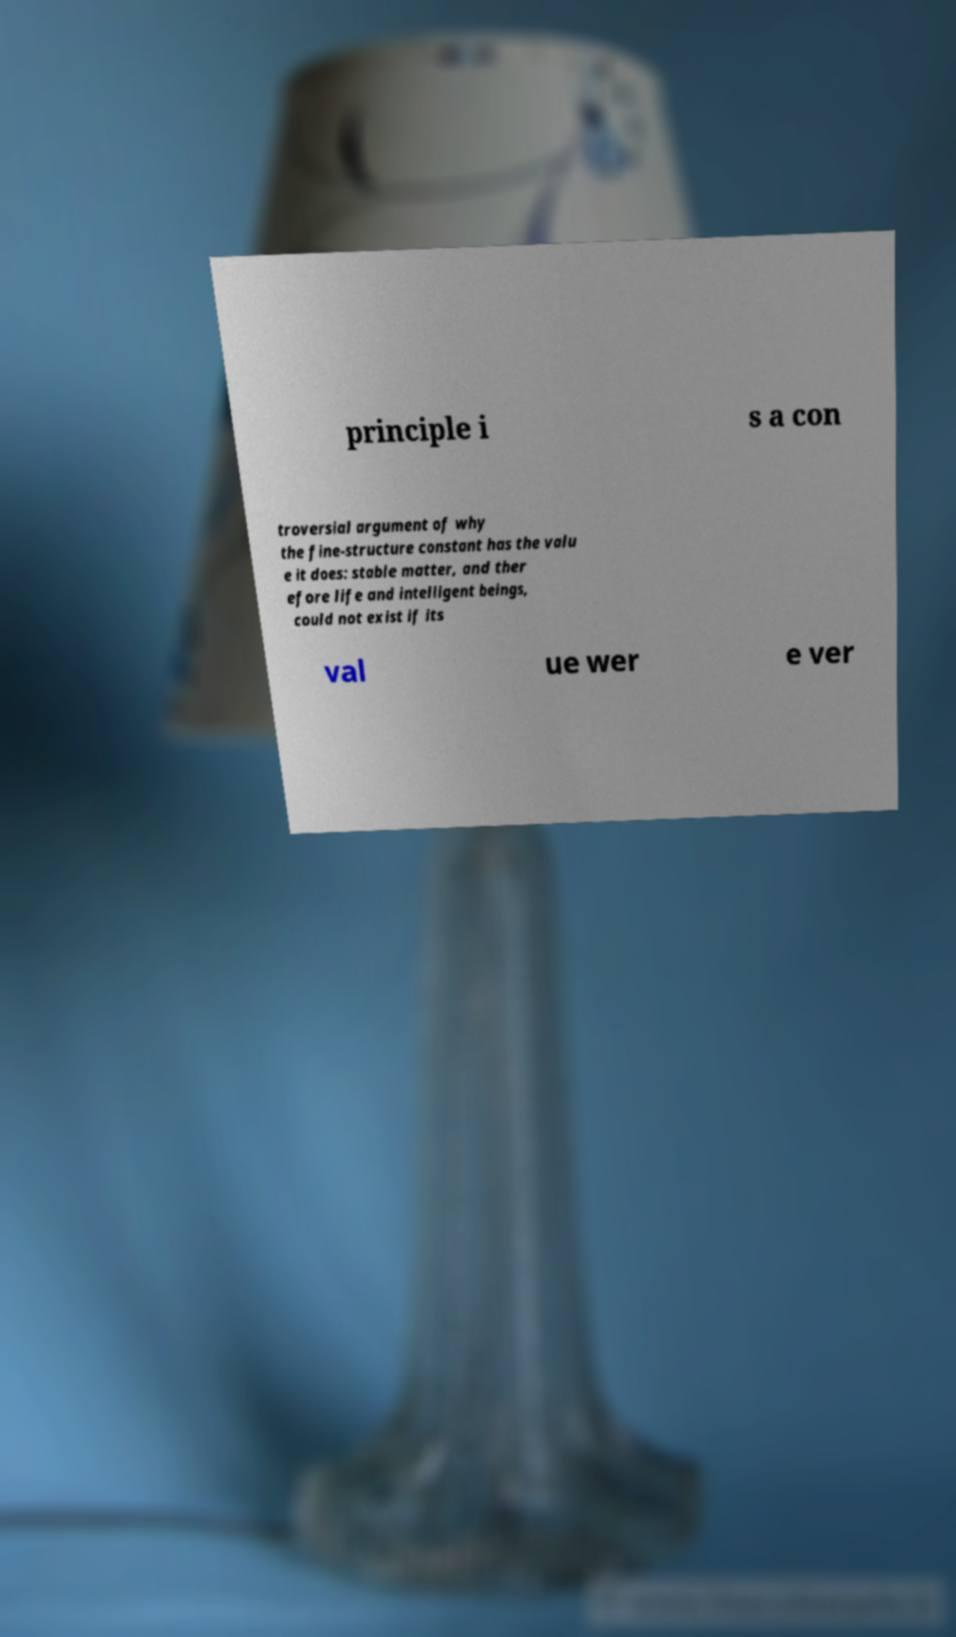Could you extract and type out the text from this image? principle i s a con troversial argument of why the fine-structure constant has the valu e it does: stable matter, and ther efore life and intelligent beings, could not exist if its val ue wer e ver 